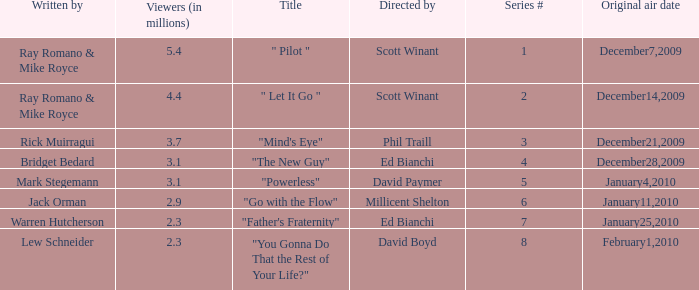What is the episode number of  "you gonna do that the rest of your life?" 8.0. Would you mind parsing the complete table? {'header': ['Written by', 'Viewers (in millions)', 'Title', 'Directed by', 'Series #', 'Original air date'], 'rows': [['Ray Romano & Mike Royce', '5.4', '" Pilot "', 'Scott Winant', '1', 'December7,2009'], ['Ray Romano & Mike Royce', '4.4', '" Let It Go "', 'Scott Winant', '2', 'December14,2009'], ['Rick Muirragui', '3.7', '"Mind\'s Eye"', 'Phil Traill', '3', 'December21,2009'], ['Bridget Bedard', '3.1', '"The New Guy"', 'Ed Bianchi', '4', 'December28,2009'], ['Mark Stegemann', '3.1', '"Powerless"', 'David Paymer', '5', 'January4,2010'], ['Jack Orman', '2.9', '"Go with the Flow"', 'Millicent Shelton', '6', 'January11,2010'], ['Warren Hutcherson', '2.3', '"Father\'s Fraternity"', 'Ed Bianchi', '7', 'January25,2010'], ['Lew Schneider', '2.3', '"You Gonna Do That the Rest of Your Life?"', 'David Boyd', '8', 'February1,2010']]} 